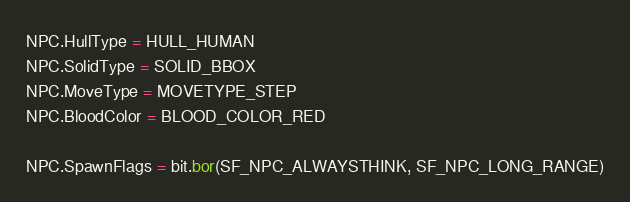<code> <loc_0><loc_0><loc_500><loc_500><_Lua_>NPC.HullType = HULL_HUMAN
NPC.SolidType = SOLID_BBOX
NPC.MoveType = MOVETYPE_STEP
NPC.BloodColor = BLOOD_COLOR_RED

NPC.SpawnFlags = bit.bor(SF_NPC_ALWAYSTHINK, SF_NPC_LONG_RANGE)</code> 